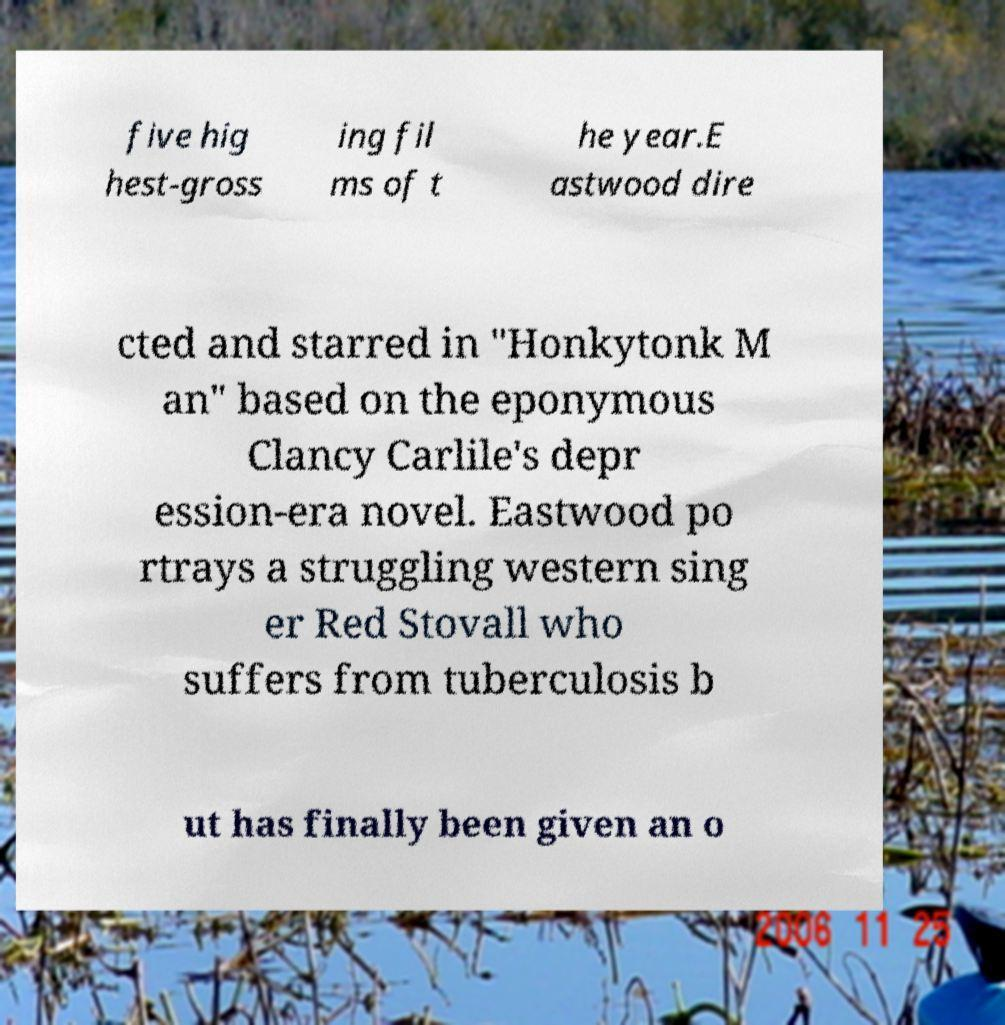Please read and relay the text visible in this image. What does it say? five hig hest-gross ing fil ms of t he year.E astwood dire cted and starred in "Honkytonk M an" based on the eponymous Clancy Carlile's depr ession-era novel. Eastwood po rtrays a struggling western sing er Red Stovall who suffers from tuberculosis b ut has finally been given an o 